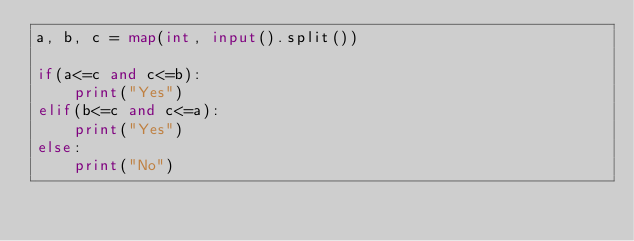Convert code to text. <code><loc_0><loc_0><loc_500><loc_500><_Python_>a, b, c = map(int, input().split())

if(a<=c and c<=b):
    print("Yes")
elif(b<=c and c<=a):
    print("Yes")
else:
    print("No")</code> 